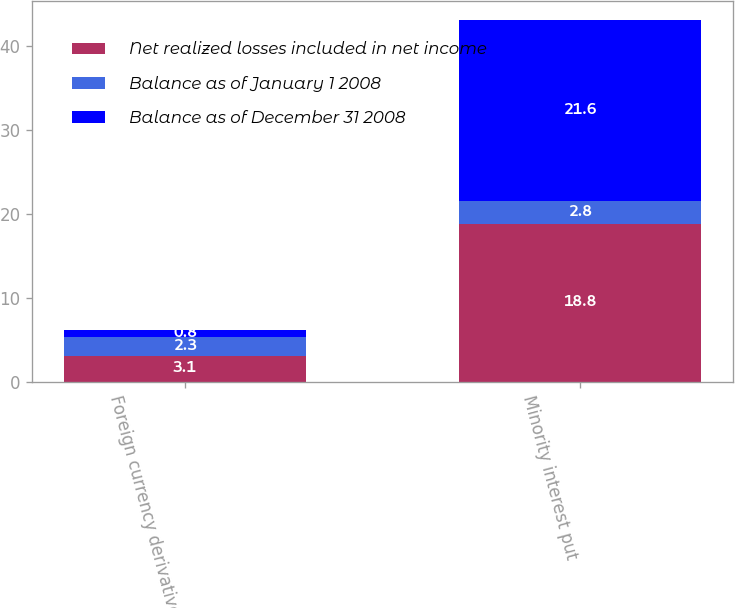<chart> <loc_0><loc_0><loc_500><loc_500><stacked_bar_chart><ecel><fcel>Foreign currency derivatives<fcel>Minority interest put<nl><fcel>Net realized losses included in net income<fcel>3.1<fcel>18.8<nl><fcel>Balance as of January 1 2008<fcel>2.3<fcel>2.8<nl><fcel>Balance as of December 31 2008<fcel>0.8<fcel>21.6<nl></chart> 